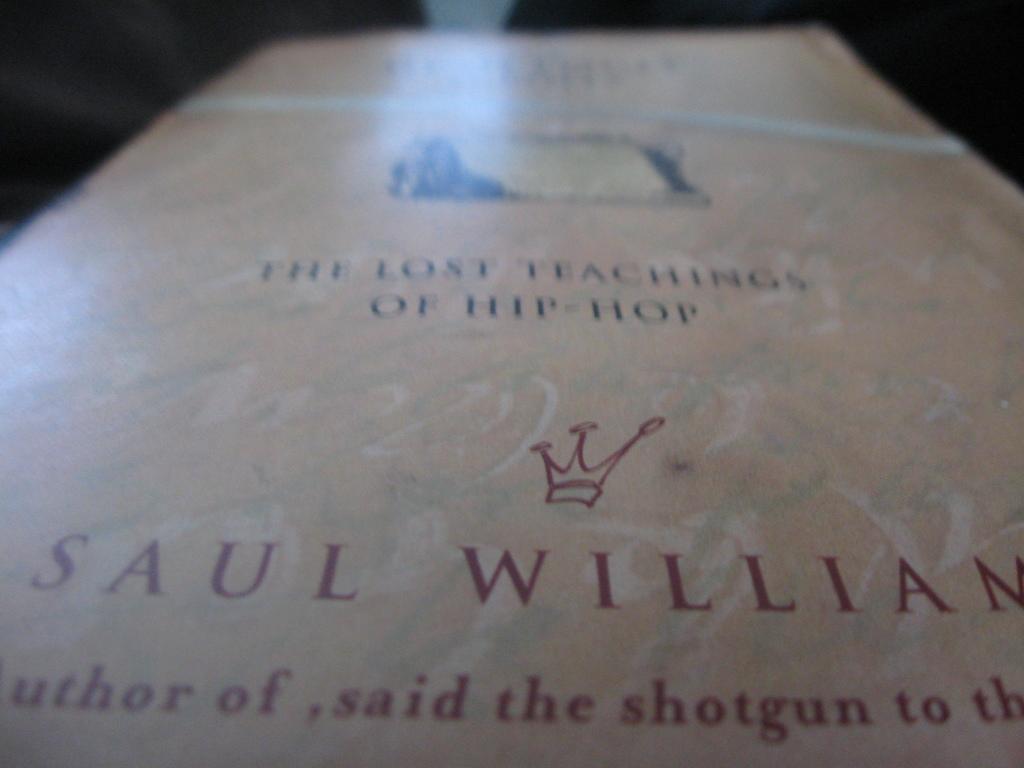Who wrote the book?
Make the answer very short. Saul william. What is the title of the book?
Provide a short and direct response. The lost teachings of hip-hop. 